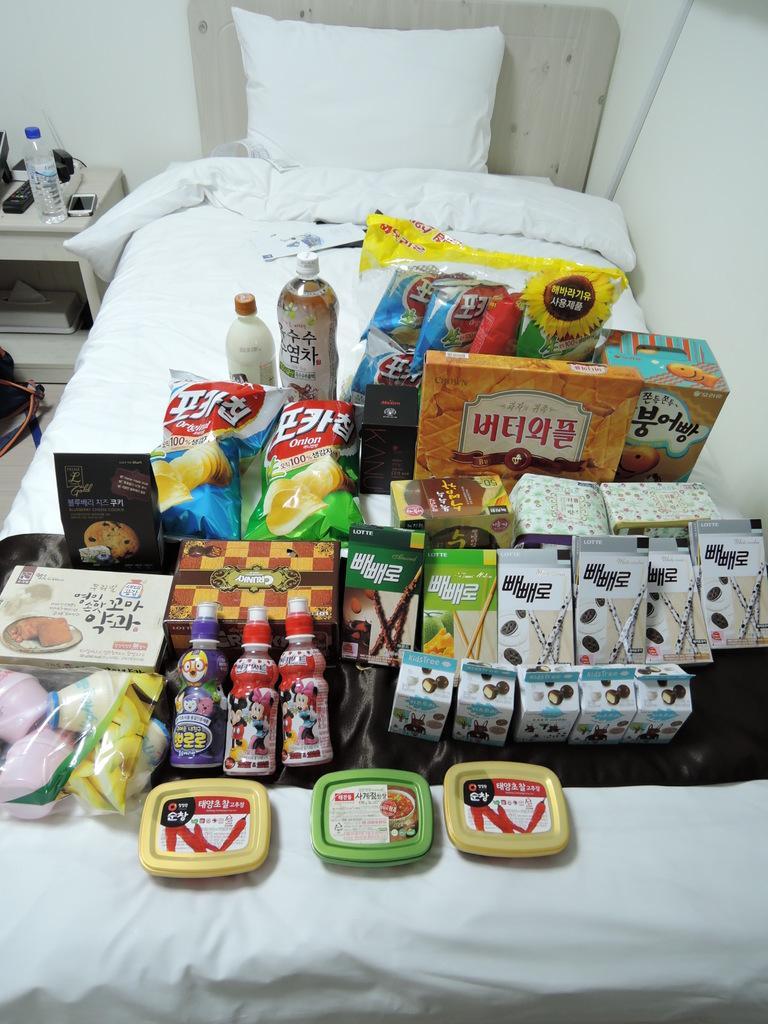Describe this image in one or two sentences. In this image there is a bed, there is a blanket on the bed, there is a pillow, there are objects on the bed, there is a table towards the left of the image, there are objects on the table, there are objects on the floor towards the left of the image, there is the wall towards the right of the image, there is a wall towards the top of the image. 